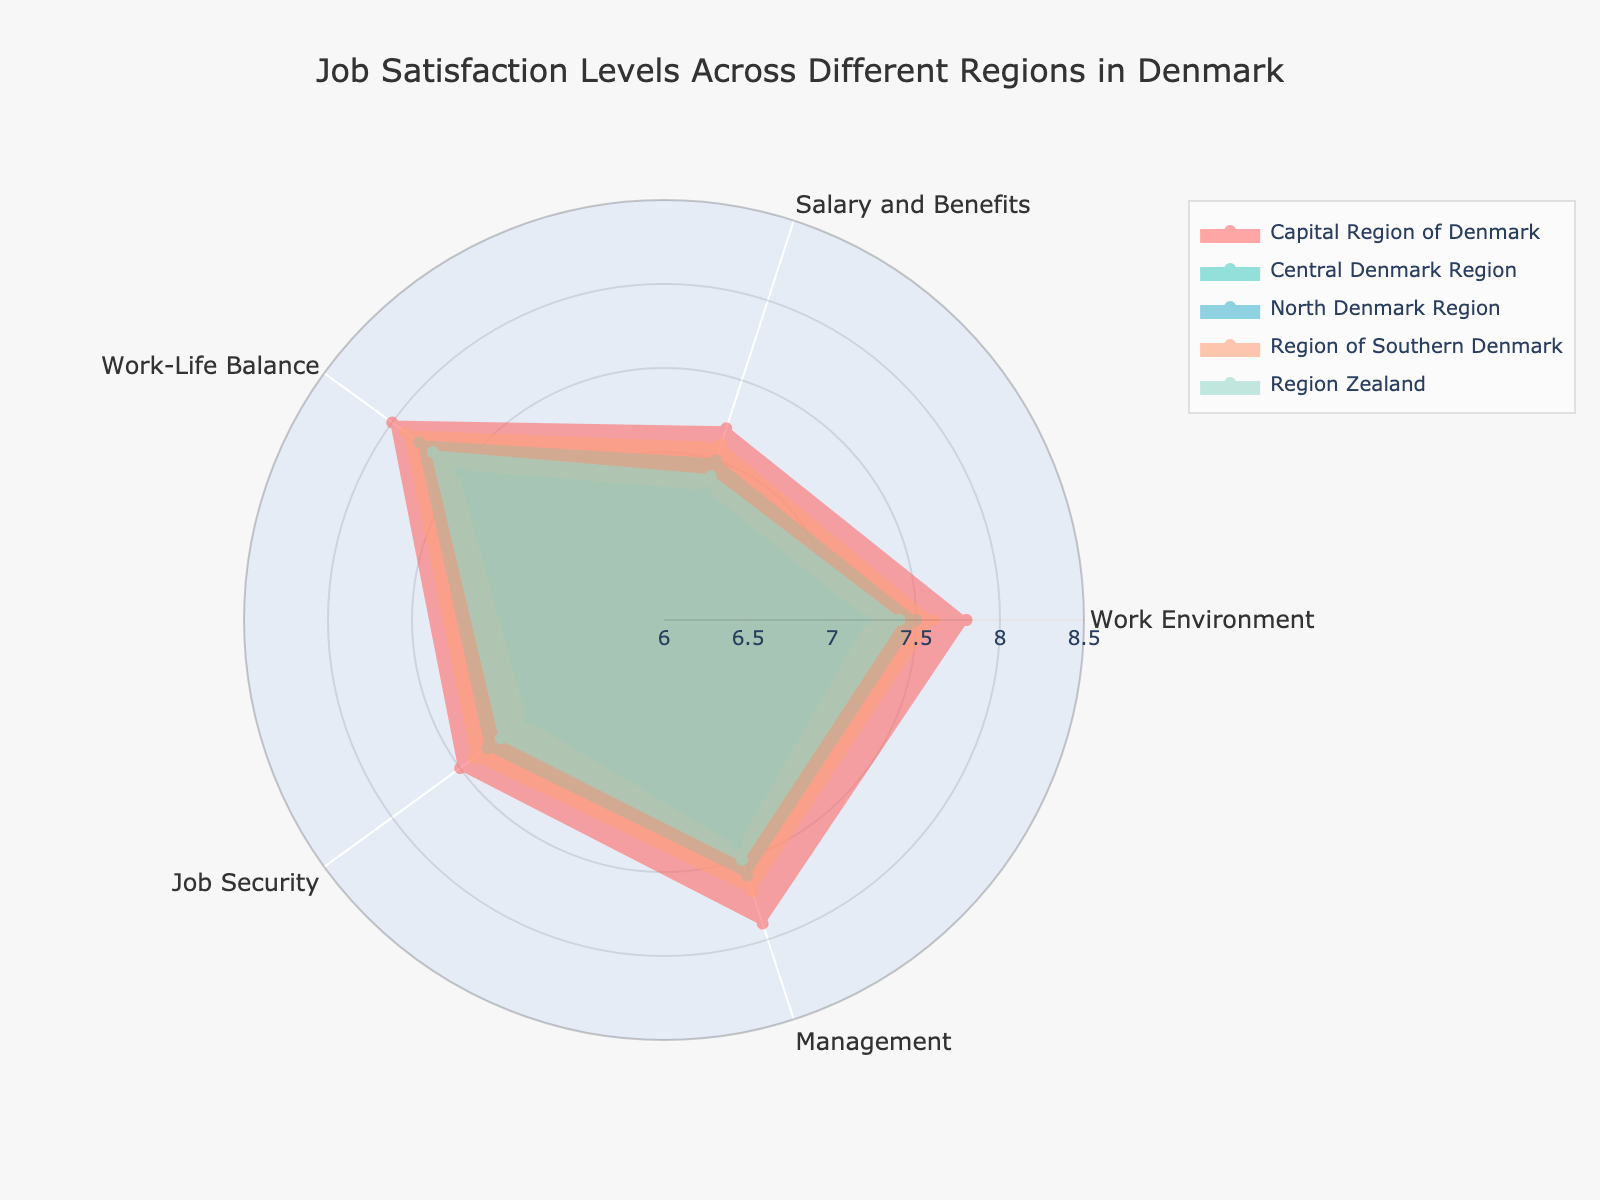what is the title of the radar chart? The title is typically displayed at the top of the chart. It describes the main subject of the figure. The title of this figure is 'Job Satisfaction Levels Across Different Regions in Denmark'.
Answer: Job Satisfaction Levels Across Different Regions in Denmark Which region has the highest job satisfaction in terms of work-life balance? To find the region with the highest job satisfaction in work-life balance, look at the work-life balance axis and identify the region with the highest value. The Capital Region of Denmark has the highest value at 8.0.
Answer: Capital Region of Denmark What are the categories measured in the radar chart? The categories measured are usually labeled around the radar chart’s edges. They include Work Environment, Salary and Benefits, Work-Life Balance, Job Security, and Management.
Answer: Work Environment, Salary and Benefits, Work-Life Balance, Job Security, Management Which region has the lowest satisfaction in terms of Salary and Benefits? To find the region with the lowest satisfaction in salary and benefits, refer to the Salary and Benefits axis. The North Denmark Region has the lowest value at 6.8.
Answer: North Denmark Region How many regions are displayed in the chart? Count the traces or regions represented by different colors. There are five regions: Capital Region of Denmark, Central Denmark Region, North Denmark Region, Region of Southern Denmark, and Region Zealand.
Answer: Five Compare the job security satisfaction between Capital Region of Denmark and Region Zealand. Look at the Job Security values for both regions. The Capital Region of Denmark has a satisfaction level of 7.5, while Region Zealand has a level of 7.2. Therefore, the Capital Region of Denmark has higher job security satisfaction.
Answer: Capital Region of Denmark Calculate the average satisfaction score for the Central Denmark Region across all categories. Add the satisfaction scores for the Central Denmark Region: 7.5 (Work Environment), 7.0 (Salary and Benefits), 7.8 (Work-Life Balance), 7.3 (Job Security), 7.6 (Management). Then divide by the number of categories (5). The average is (7.5 + 7.0 + 7.8 + 7.3 + 7.6) / 5 = 7.44.
Answer: 7.44 Which category shows the least variance in satisfaction levels across all regions? Look at the spread of values for each category. The category with the smallest range of values indicates the least variance. Job Security varies from 7.0 to 7.5, making it the least variable category.
Answer: Job Security 